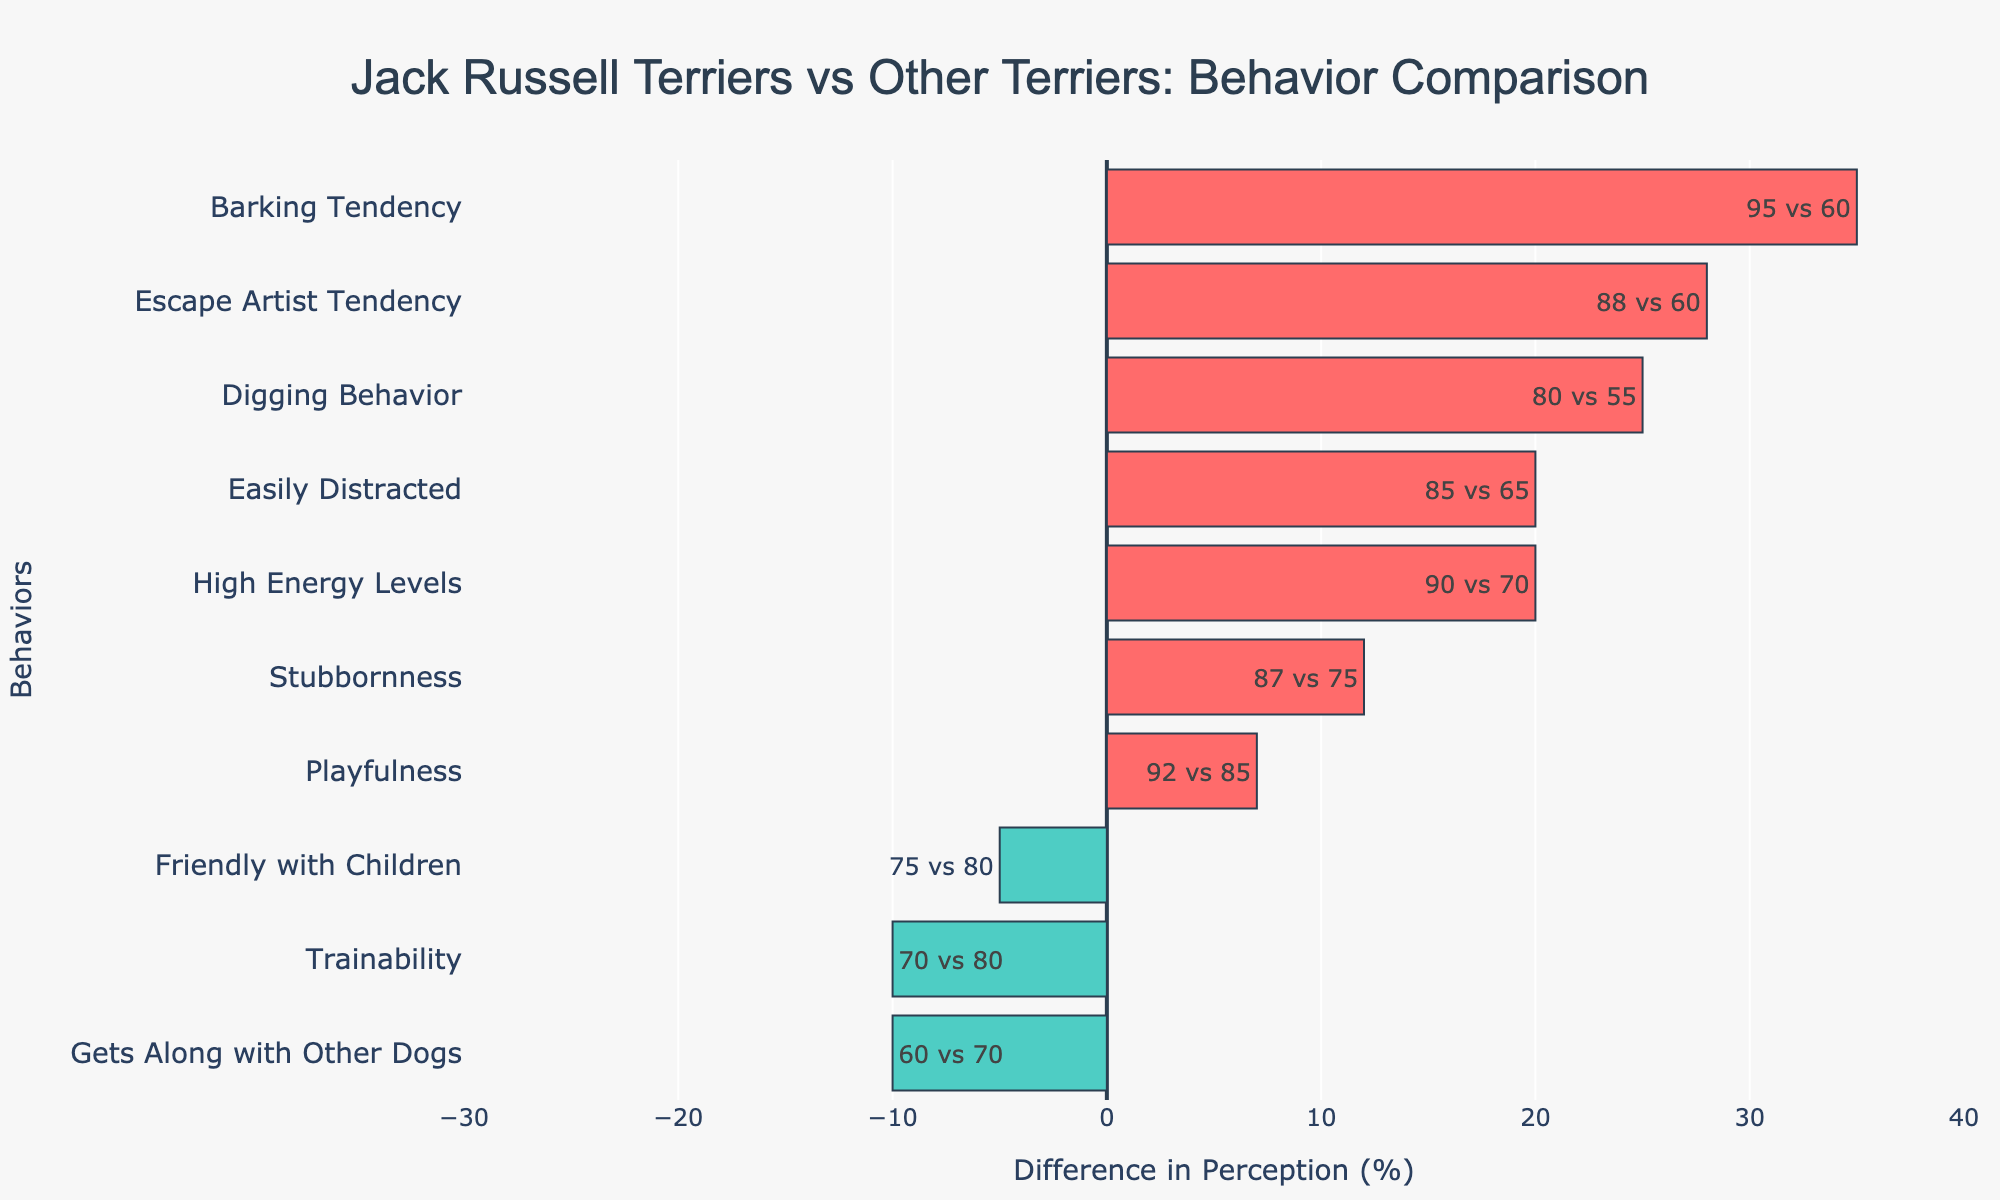How much more likely are Jack Russell Terriers to exhibit a high energy level compared to other terriers? The "High Energy Levels" bar is further to the right for Jack Russell Terriers (90%) compared to other terriers (70%). The difference is 90% - 70% = 20%.
Answer: 20% Which behavior has the greatest difference between Jack Russell Terriers and other terriers? The "Barking Tendency" behavior has a far greater difference, with Jack Russell Terriers at 95% and other terriers at 60%. The difference is 35%.
Answer: Barking Tendency Are Jack Russell Terriers more or less likely to be friendly with children compared to other terriers? Jack Russell Terriers are represented by a negative bar for "Friendly with Children," showing that they are rated 75%, whereas other terriers are rated 80%. This indicates that Jack Russell Terriers are less likely to be friendly with children.
Answer: Less likely Which behaviors are more likely to occur in Jack Russell Terriers than in other terriers based on visual cues? Behaviors represented by red-colored bars indicate that Jack Russell Terriers score higher, which includes "High Energy Levels," "Easily Distracted," "Barking Tendency," "Digging Behavior," "Stubbornness," "Playfulness," and "Escape Artist Tendency."
Answer: High Energy Levels, Easily Distracted, Barking Tendency, Digging Behavior, Stubbornness, Playfulness, Escape Artist Tendency What is the combined difference in perception for "Trainability" and "Gets Along with Other Dogs"? For "Trainability," Jack Russell Terriers score 70% and other terriers score 80% (difference of -10%). For "Gets Along with Other Dogs," Jack Russell Terriers score 60% and other terriers score 70% (difference of -10%). Combined difference = -10% + -10% = -20%.
Answer: -20% Which breed is perceived to be better at getting along with other dogs? The "Gets Along with Other Dogs" behavior shows that other terriers have a score of 70% compared to Jack Russell Terriers' 60%, indicating that other terriers are perceived to be better at this behavior.
Answer: Other Terriers Is the "Playfulness" behavior scored significantly differently between the two breeds? Both Jack Russell Terriers and other terriers score highly on "Playfulness" with values of 92% and 85%, respectively. The difference is 7%, which is not too significant compared to other behaviors.
Answer: No What behavior indicates the highest stubbornness in Jack Russell Terriers compared to other terriers? "Stubbornness" behavior has Jack Russell Terriers at 87% and other terriers at 75%, making the difference 12%.
Answer: Stubbornness 